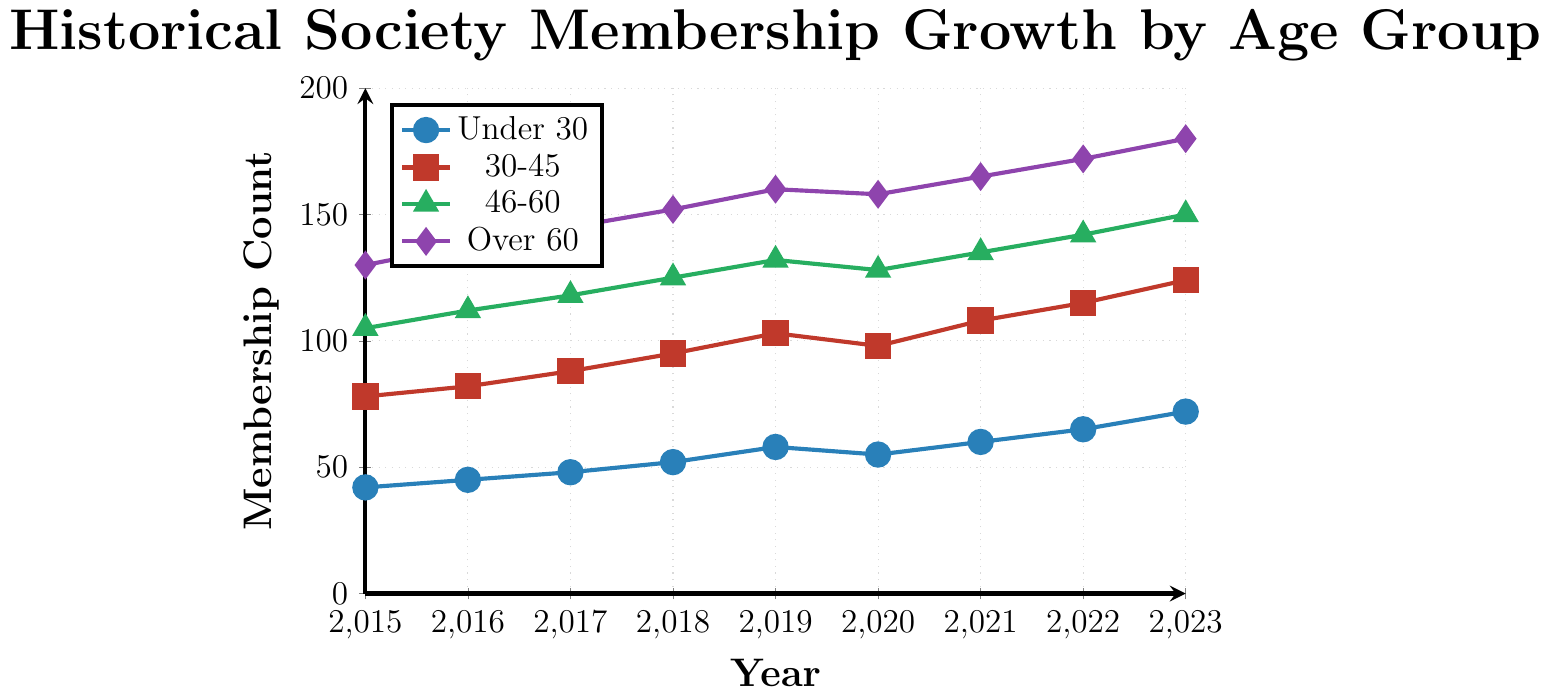What's the membership count for the "Over 60" group in 2015? By looking at the "Over 60" line on the plot for the year 2015, the value is 130.
Answer: 130 Which age group had the largest increase in membership from 2015 to 2023? Calculate the increase for each group by subtracting the 2015 membership from the 2023 membership: "Under 30" increased by 30 (72-42), "30-45" by 46 (124-78), "46-60" by 45 (150-105), and "Over 60" by 50 (180-130). The "Over 60" group had the largest increase of 50 members.
Answer: Over 60 What is the average membership count for the "46-60" group over the years 2015-2023? Sum the membership values for the "46-60" group from 2015 to 2023 and divide by the number of years: (105 + 112 + 118 + 125 + 132 + 128 + 135 + 142 + 150) / 9 = 124.11
Answer: 124.11 In which year did the "Under 30" group experience a decline in membership compared to the previous year? Identify the year where the "Under 30" group's values decrease: Membership decreased from 58 in 2019 to 55 in 2020.
Answer: 2020 How did the membership count for the "30-45" group in 2020 compare to that in 2019? Subtract the 2019 value from the 2020 value for the "30-45" group: 98 (2020) - 103 (2019) = -5. The membership count decreased by 5 members.
Answer: Decreased by 5 Which group had the highest membership in 2022? Compare membership values for all groups in 2022: "Under 30" (65), "30-45" (115), "46-60" (142), and "Over 60" (172). The "Over 60" group has the highest membership in 2022.
Answer: Over 60 What is the total membership count in 2023 across all age groups? Sum the membership values for all age groups in 2023: 72 (Under 30) + 124 (30-45) + 150 (46-60) + 180 (Over 60) = 526.
Answer: 526 By how much did the membership in the "30-45" group increase from 2018 to 2021? Subtract the 2018 value from the 2021 value for the "30-45" group: 108 (2021) - 95 (2018) = 13.
Answer: 13 Which age group showed the most consistent growth over the years 2015-2023? "Consistent growth" means steadily increasing every year. By observing the lines, the "Over 60" group shows consistent growth without any declines.
Answer: Over 60 